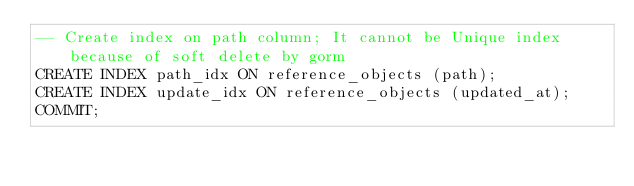<code> <loc_0><loc_0><loc_500><loc_500><_SQL_>-- Create index on path column; It cannot be Unique index because of soft delete by gorm
CREATE INDEX path_idx ON reference_objects (path);
CREATE INDEX update_idx ON reference_objects (updated_at);
COMMIT;</code> 